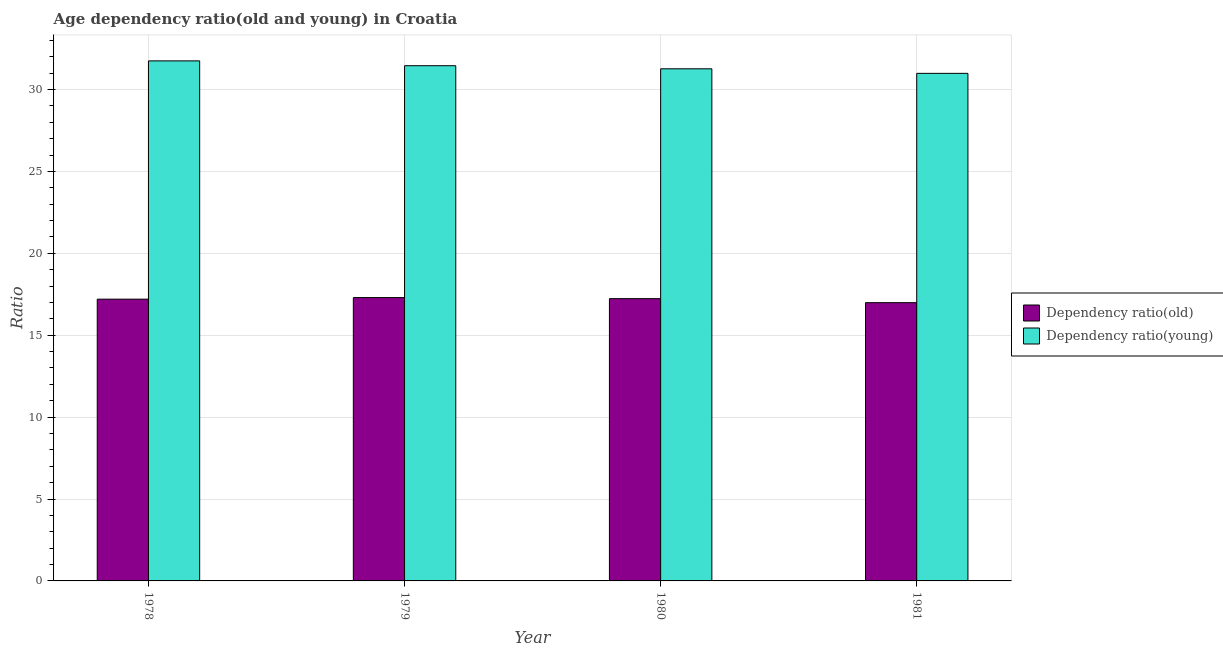How many different coloured bars are there?
Your answer should be compact. 2. Are the number of bars per tick equal to the number of legend labels?
Provide a succinct answer. Yes. Are the number of bars on each tick of the X-axis equal?
Offer a terse response. Yes. How many bars are there on the 4th tick from the left?
Offer a terse response. 2. What is the label of the 1st group of bars from the left?
Keep it short and to the point. 1978. What is the age dependency ratio(young) in 1980?
Provide a succinct answer. 31.27. Across all years, what is the maximum age dependency ratio(young)?
Make the answer very short. 31.75. Across all years, what is the minimum age dependency ratio(young)?
Provide a succinct answer. 30.99. In which year was the age dependency ratio(young) maximum?
Your answer should be compact. 1978. What is the total age dependency ratio(old) in the graph?
Offer a very short reply. 68.72. What is the difference between the age dependency ratio(old) in 1978 and that in 1981?
Offer a terse response. 0.21. What is the difference between the age dependency ratio(old) in 1979 and the age dependency ratio(young) in 1980?
Provide a short and direct response. 0.06. What is the average age dependency ratio(old) per year?
Offer a terse response. 17.18. What is the ratio of the age dependency ratio(young) in 1978 to that in 1981?
Your response must be concise. 1.02. Is the difference between the age dependency ratio(old) in 1978 and 1981 greater than the difference between the age dependency ratio(young) in 1978 and 1981?
Provide a succinct answer. No. What is the difference between the highest and the second highest age dependency ratio(young)?
Offer a terse response. 0.3. What is the difference between the highest and the lowest age dependency ratio(young)?
Provide a short and direct response. 0.76. What does the 2nd bar from the left in 1979 represents?
Your answer should be very brief. Dependency ratio(young). What does the 2nd bar from the right in 1980 represents?
Your answer should be compact. Dependency ratio(old). How many bars are there?
Give a very brief answer. 8. How many years are there in the graph?
Your response must be concise. 4. What is the difference between two consecutive major ticks on the Y-axis?
Provide a short and direct response. 5. Are the values on the major ticks of Y-axis written in scientific E-notation?
Your answer should be very brief. No. Does the graph contain grids?
Offer a terse response. Yes. Where does the legend appear in the graph?
Your answer should be very brief. Center right. How are the legend labels stacked?
Provide a succinct answer. Vertical. What is the title of the graph?
Offer a terse response. Age dependency ratio(old and young) in Croatia. Does "Electricity and heat production" appear as one of the legend labels in the graph?
Keep it short and to the point. No. What is the label or title of the X-axis?
Ensure brevity in your answer.  Year. What is the label or title of the Y-axis?
Your response must be concise. Ratio. What is the Ratio of Dependency ratio(old) in 1978?
Offer a terse response. 17.2. What is the Ratio in Dependency ratio(young) in 1978?
Provide a succinct answer. 31.75. What is the Ratio of Dependency ratio(old) in 1979?
Give a very brief answer. 17.3. What is the Ratio in Dependency ratio(young) in 1979?
Offer a terse response. 31.46. What is the Ratio of Dependency ratio(old) in 1980?
Make the answer very short. 17.23. What is the Ratio in Dependency ratio(young) in 1980?
Ensure brevity in your answer.  31.27. What is the Ratio of Dependency ratio(old) in 1981?
Make the answer very short. 16.99. What is the Ratio of Dependency ratio(young) in 1981?
Ensure brevity in your answer.  30.99. Across all years, what is the maximum Ratio in Dependency ratio(old)?
Your response must be concise. 17.3. Across all years, what is the maximum Ratio of Dependency ratio(young)?
Your answer should be compact. 31.75. Across all years, what is the minimum Ratio of Dependency ratio(old)?
Your response must be concise. 16.99. Across all years, what is the minimum Ratio in Dependency ratio(young)?
Give a very brief answer. 30.99. What is the total Ratio in Dependency ratio(old) in the graph?
Ensure brevity in your answer.  68.72. What is the total Ratio in Dependency ratio(young) in the graph?
Offer a terse response. 125.46. What is the difference between the Ratio in Dependency ratio(old) in 1978 and that in 1979?
Your response must be concise. -0.1. What is the difference between the Ratio of Dependency ratio(young) in 1978 and that in 1979?
Offer a very short reply. 0.3. What is the difference between the Ratio in Dependency ratio(old) in 1978 and that in 1980?
Provide a short and direct response. -0.03. What is the difference between the Ratio of Dependency ratio(young) in 1978 and that in 1980?
Provide a short and direct response. 0.48. What is the difference between the Ratio in Dependency ratio(old) in 1978 and that in 1981?
Give a very brief answer. 0.21. What is the difference between the Ratio in Dependency ratio(young) in 1978 and that in 1981?
Your response must be concise. 0.76. What is the difference between the Ratio of Dependency ratio(old) in 1979 and that in 1980?
Ensure brevity in your answer.  0.06. What is the difference between the Ratio of Dependency ratio(young) in 1979 and that in 1980?
Ensure brevity in your answer.  0.19. What is the difference between the Ratio of Dependency ratio(old) in 1979 and that in 1981?
Offer a terse response. 0.31. What is the difference between the Ratio in Dependency ratio(young) in 1979 and that in 1981?
Your answer should be very brief. 0.47. What is the difference between the Ratio in Dependency ratio(old) in 1980 and that in 1981?
Keep it short and to the point. 0.24. What is the difference between the Ratio of Dependency ratio(young) in 1980 and that in 1981?
Offer a very short reply. 0.28. What is the difference between the Ratio in Dependency ratio(old) in 1978 and the Ratio in Dependency ratio(young) in 1979?
Ensure brevity in your answer.  -14.25. What is the difference between the Ratio of Dependency ratio(old) in 1978 and the Ratio of Dependency ratio(young) in 1980?
Ensure brevity in your answer.  -14.06. What is the difference between the Ratio in Dependency ratio(old) in 1978 and the Ratio in Dependency ratio(young) in 1981?
Offer a terse response. -13.79. What is the difference between the Ratio in Dependency ratio(old) in 1979 and the Ratio in Dependency ratio(young) in 1980?
Your answer should be compact. -13.97. What is the difference between the Ratio in Dependency ratio(old) in 1979 and the Ratio in Dependency ratio(young) in 1981?
Your answer should be compact. -13.69. What is the difference between the Ratio of Dependency ratio(old) in 1980 and the Ratio of Dependency ratio(young) in 1981?
Give a very brief answer. -13.76. What is the average Ratio in Dependency ratio(old) per year?
Make the answer very short. 17.18. What is the average Ratio of Dependency ratio(young) per year?
Provide a short and direct response. 31.37. In the year 1978, what is the difference between the Ratio of Dependency ratio(old) and Ratio of Dependency ratio(young)?
Ensure brevity in your answer.  -14.55. In the year 1979, what is the difference between the Ratio of Dependency ratio(old) and Ratio of Dependency ratio(young)?
Ensure brevity in your answer.  -14.16. In the year 1980, what is the difference between the Ratio of Dependency ratio(old) and Ratio of Dependency ratio(young)?
Keep it short and to the point. -14.03. In the year 1981, what is the difference between the Ratio in Dependency ratio(old) and Ratio in Dependency ratio(young)?
Keep it short and to the point. -14. What is the ratio of the Ratio of Dependency ratio(old) in 1978 to that in 1979?
Give a very brief answer. 0.99. What is the ratio of the Ratio of Dependency ratio(young) in 1978 to that in 1979?
Give a very brief answer. 1.01. What is the ratio of the Ratio of Dependency ratio(young) in 1978 to that in 1980?
Ensure brevity in your answer.  1.02. What is the ratio of the Ratio in Dependency ratio(old) in 1978 to that in 1981?
Offer a very short reply. 1.01. What is the ratio of the Ratio of Dependency ratio(young) in 1978 to that in 1981?
Your answer should be compact. 1.02. What is the ratio of the Ratio in Dependency ratio(old) in 1979 to that in 1980?
Make the answer very short. 1. What is the ratio of the Ratio of Dependency ratio(young) in 1979 to that in 1980?
Offer a very short reply. 1.01. What is the ratio of the Ratio of Dependency ratio(old) in 1979 to that in 1981?
Ensure brevity in your answer.  1.02. What is the ratio of the Ratio of Dependency ratio(young) in 1979 to that in 1981?
Provide a short and direct response. 1.02. What is the ratio of the Ratio in Dependency ratio(old) in 1980 to that in 1981?
Give a very brief answer. 1.01. What is the ratio of the Ratio of Dependency ratio(young) in 1980 to that in 1981?
Keep it short and to the point. 1.01. What is the difference between the highest and the second highest Ratio of Dependency ratio(old)?
Offer a very short reply. 0.06. What is the difference between the highest and the second highest Ratio in Dependency ratio(young)?
Your answer should be compact. 0.3. What is the difference between the highest and the lowest Ratio in Dependency ratio(old)?
Make the answer very short. 0.31. What is the difference between the highest and the lowest Ratio in Dependency ratio(young)?
Offer a terse response. 0.76. 